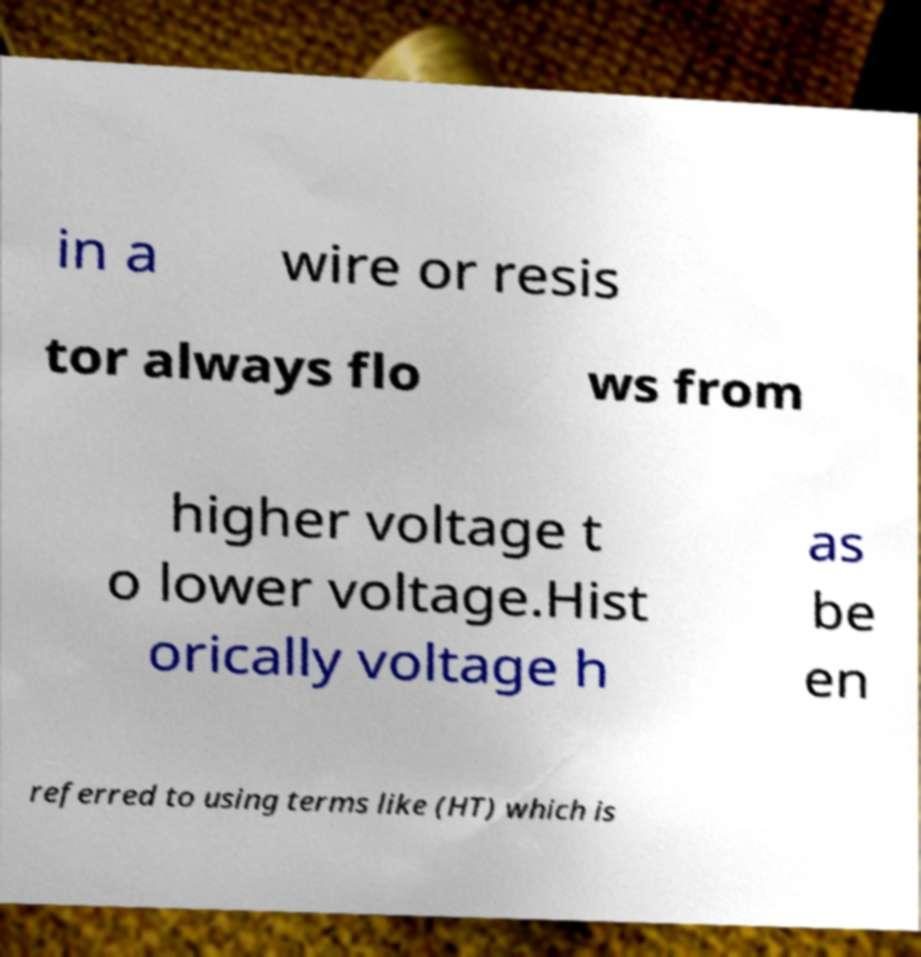I need the written content from this picture converted into text. Can you do that? in a wire or resis tor always flo ws from higher voltage t o lower voltage.Hist orically voltage h as be en referred to using terms like (HT) which is 